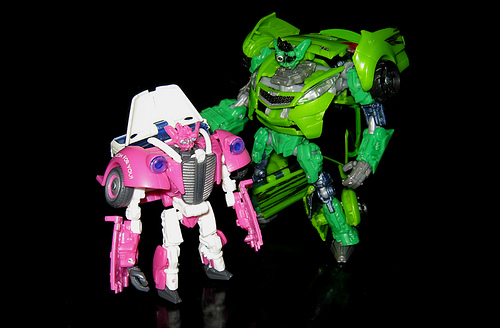<image>
Can you confirm if the green robot is to the left of the pink robot? Yes. From this viewpoint, the green robot is positioned to the left side relative to the pink robot. 